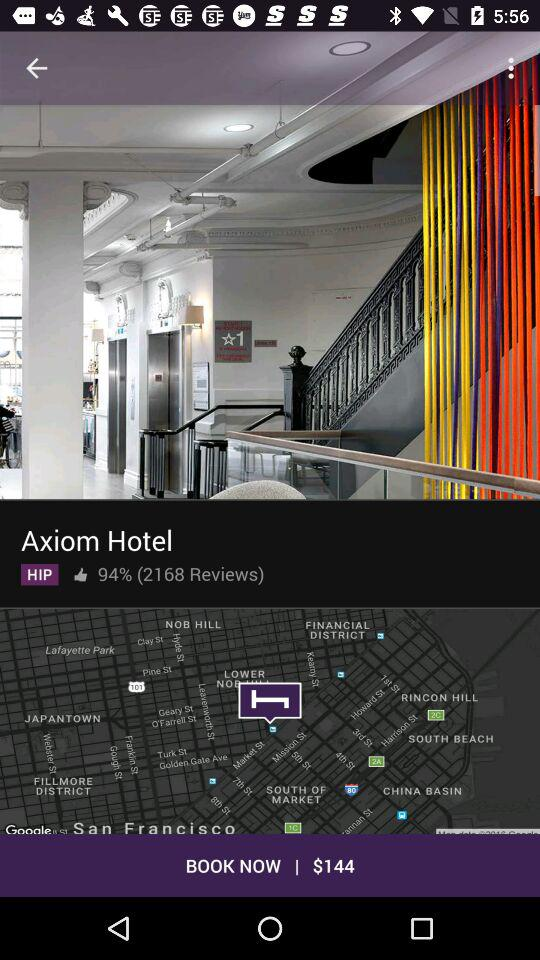How many reviews are there for the Axiom Hotel? There are 2168 reviews. 